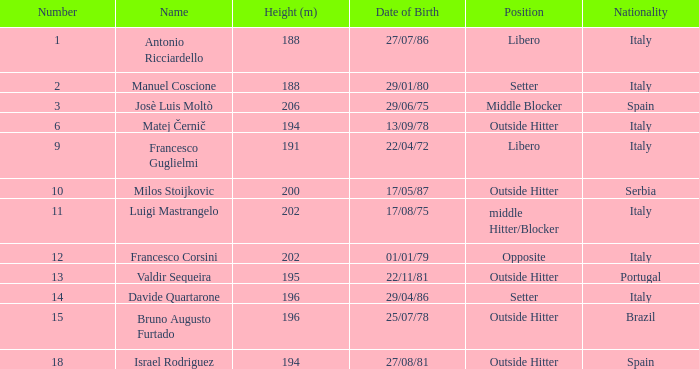Name the date of birth for 27/07/86 Antonio Ricciardello. 